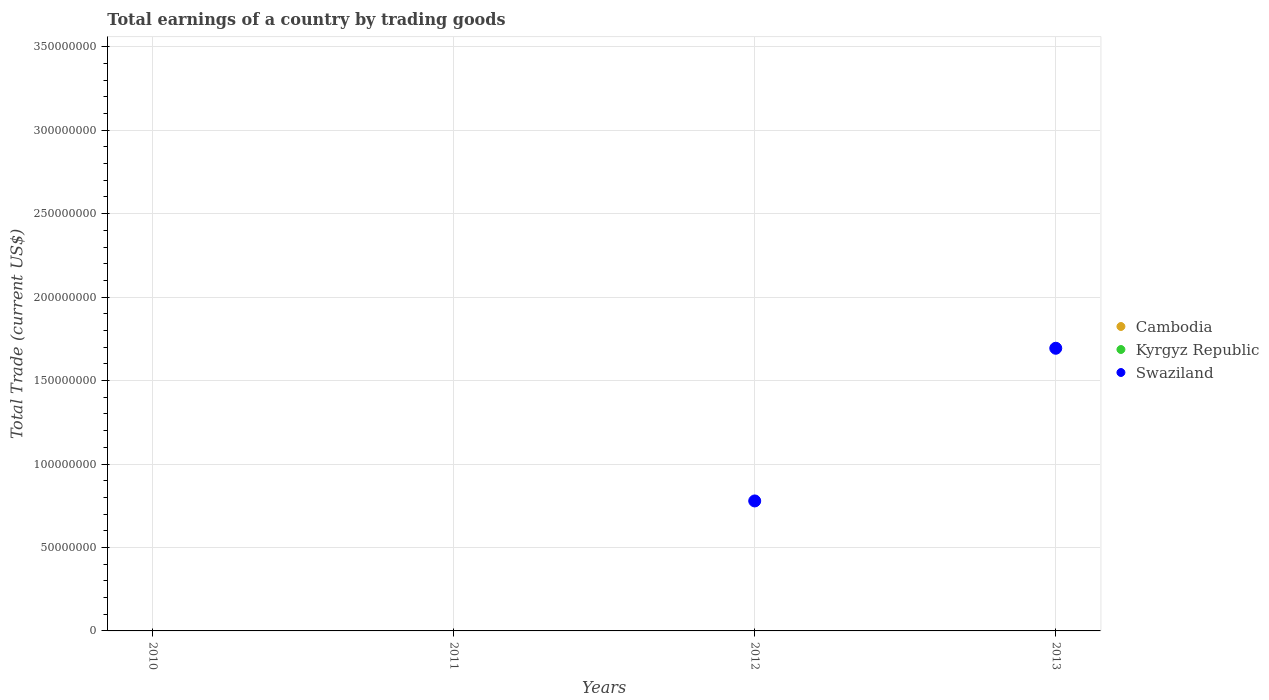How many different coloured dotlines are there?
Your answer should be compact. 1. What is the total earnings in Swaziland in 2013?
Give a very brief answer. 1.69e+08. Across all years, what is the maximum total earnings in Swaziland?
Your answer should be compact. 1.69e+08. Across all years, what is the minimum total earnings in Cambodia?
Offer a terse response. 0. In which year was the total earnings in Swaziland maximum?
Your response must be concise. 2013. What is the difference between the total earnings in Swaziland in 2012 and that in 2013?
Ensure brevity in your answer.  -9.15e+07. What is the difference between the highest and the lowest total earnings in Swaziland?
Keep it short and to the point. 1.69e+08. In how many years, is the total earnings in Kyrgyz Republic greater than the average total earnings in Kyrgyz Republic taken over all years?
Ensure brevity in your answer.  0. Is it the case that in every year, the sum of the total earnings in Kyrgyz Republic and total earnings in Swaziland  is greater than the total earnings in Cambodia?
Provide a short and direct response. No. Is the total earnings in Kyrgyz Republic strictly less than the total earnings in Cambodia over the years?
Provide a short and direct response. No. How many years are there in the graph?
Your answer should be compact. 4. Are the values on the major ticks of Y-axis written in scientific E-notation?
Offer a terse response. No. Does the graph contain any zero values?
Give a very brief answer. Yes. Where does the legend appear in the graph?
Give a very brief answer. Center right. What is the title of the graph?
Your answer should be compact. Total earnings of a country by trading goods. What is the label or title of the Y-axis?
Make the answer very short. Total Trade (current US$). What is the Total Trade (current US$) of Cambodia in 2010?
Your answer should be very brief. 0. What is the Total Trade (current US$) of Kyrgyz Republic in 2010?
Provide a succinct answer. 0. What is the Total Trade (current US$) of Swaziland in 2010?
Your answer should be compact. 0. What is the Total Trade (current US$) in Cambodia in 2011?
Give a very brief answer. 0. What is the Total Trade (current US$) in Swaziland in 2011?
Provide a succinct answer. 0. What is the Total Trade (current US$) of Swaziland in 2012?
Keep it short and to the point. 7.79e+07. What is the Total Trade (current US$) of Cambodia in 2013?
Offer a terse response. 0. What is the Total Trade (current US$) of Swaziland in 2013?
Provide a short and direct response. 1.69e+08. Across all years, what is the maximum Total Trade (current US$) in Swaziland?
Your answer should be very brief. 1.69e+08. What is the total Total Trade (current US$) in Swaziland in the graph?
Offer a terse response. 2.47e+08. What is the difference between the Total Trade (current US$) in Swaziland in 2012 and that in 2013?
Give a very brief answer. -9.15e+07. What is the average Total Trade (current US$) of Cambodia per year?
Give a very brief answer. 0. What is the average Total Trade (current US$) in Kyrgyz Republic per year?
Your response must be concise. 0. What is the average Total Trade (current US$) in Swaziland per year?
Keep it short and to the point. 6.18e+07. What is the ratio of the Total Trade (current US$) of Swaziland in 2012 to that in 2013?
Make the answer very short. 0.46. What is the difference between the highest and the lowest Total Trade (current US$) in Swaziland?
Give a very brief answer. 1.69e+08. 